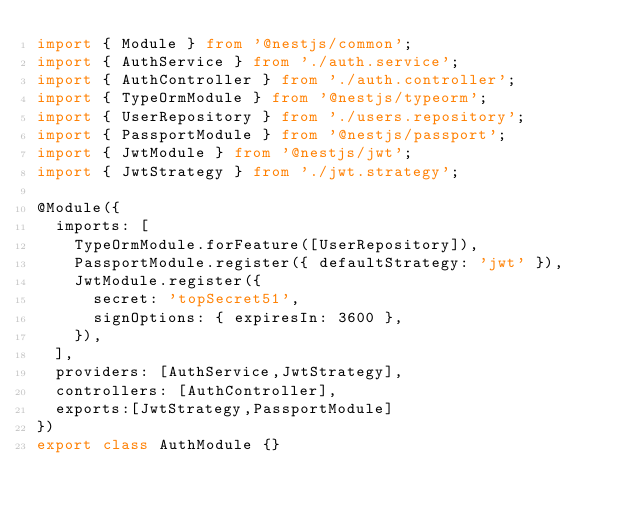<code> <loc_0><loc_0><loc_500><loc_500><_TypeScript_>import { Module } from '@nestjs/common';
import { AuthService } from './auth.service';
import { AuthController } from './auth.controller';
import { TypeOrmModule } from '@nestjs/typeorm';
import { UserRepository } from './users.repository';
import { PassportModule } from '@nestjs/passport';
import { JwtModule } from '@nestjs/jwt';
import { JwtStrategy } from './jwt.strategy';

@Module({
  imports: [
    TypeOrmModule.forFeature([UserRepository]),
    PassportModule.register({ defaultStrategy: 'jwt' }),
    JwtModule.register({
      secret: 'topSecret51',
      signOptions: { expiresIn: 3600 },
    }),
  ],
  providers: [AuthService,JwtStrategy],
  controllers: [AuthController],
  exports:[JwtStrategy,PassportModule]
})
export class AuthModule {}
</code> 